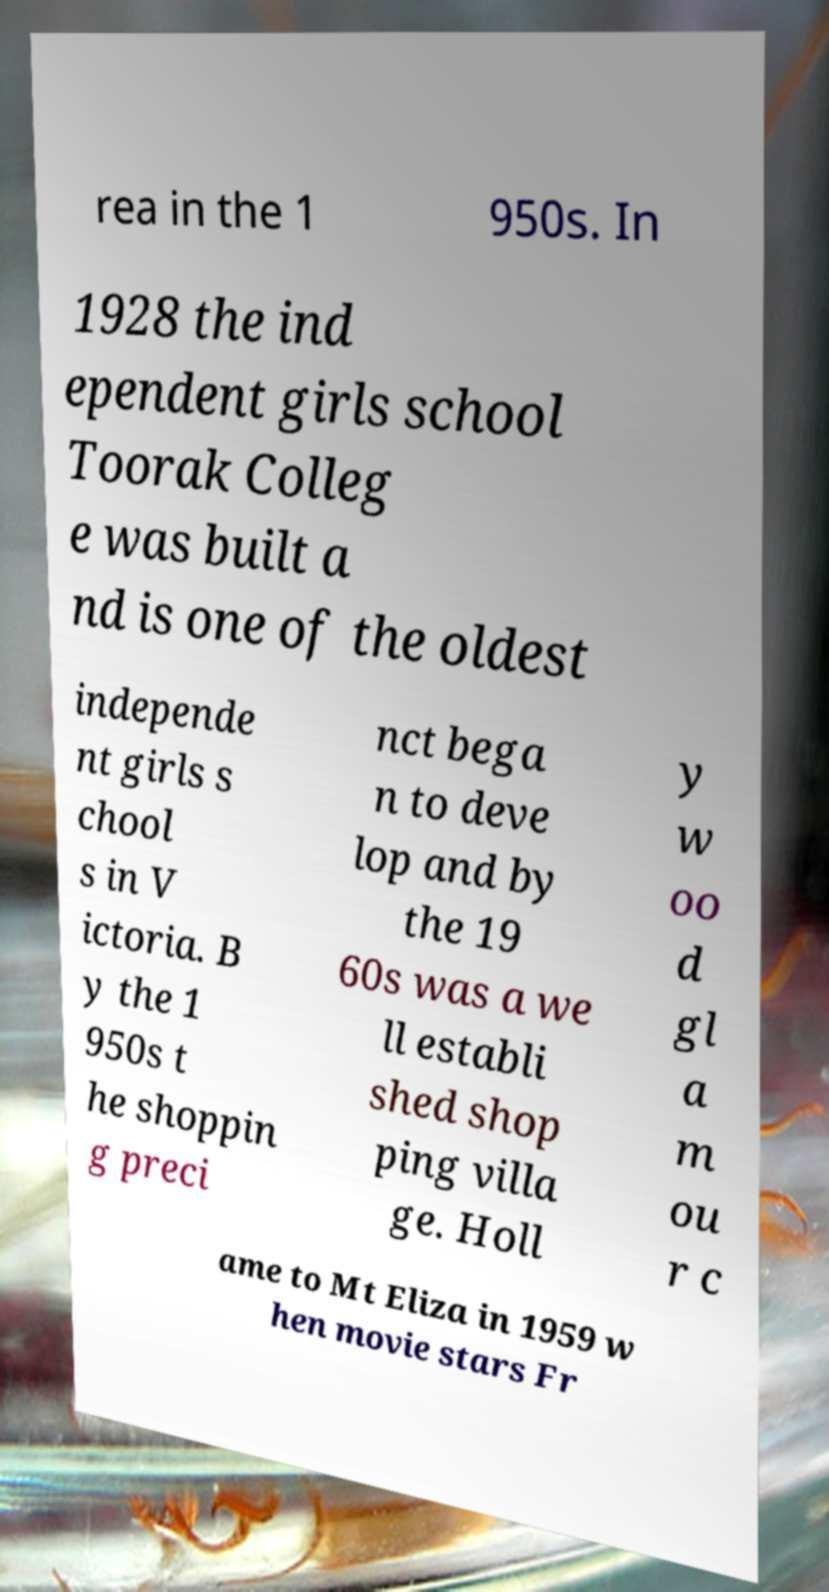I need the written content from this picture converted into text. Can you do that? rea in the 1 950s. In 1928 the ind ependent girls school Toorak Colleg e was built a nd is one of the oldest independe nt girls s chool s in V ictoria. B y the 1 950s t he shoppin g preci nct bega n to deve lop and by the 19 60s was a we ll establi shed shop ping villa ge. Holl y w oo d gl a m ou r c ame to Mt Eliza in 1959 w hen movie stars Fr 